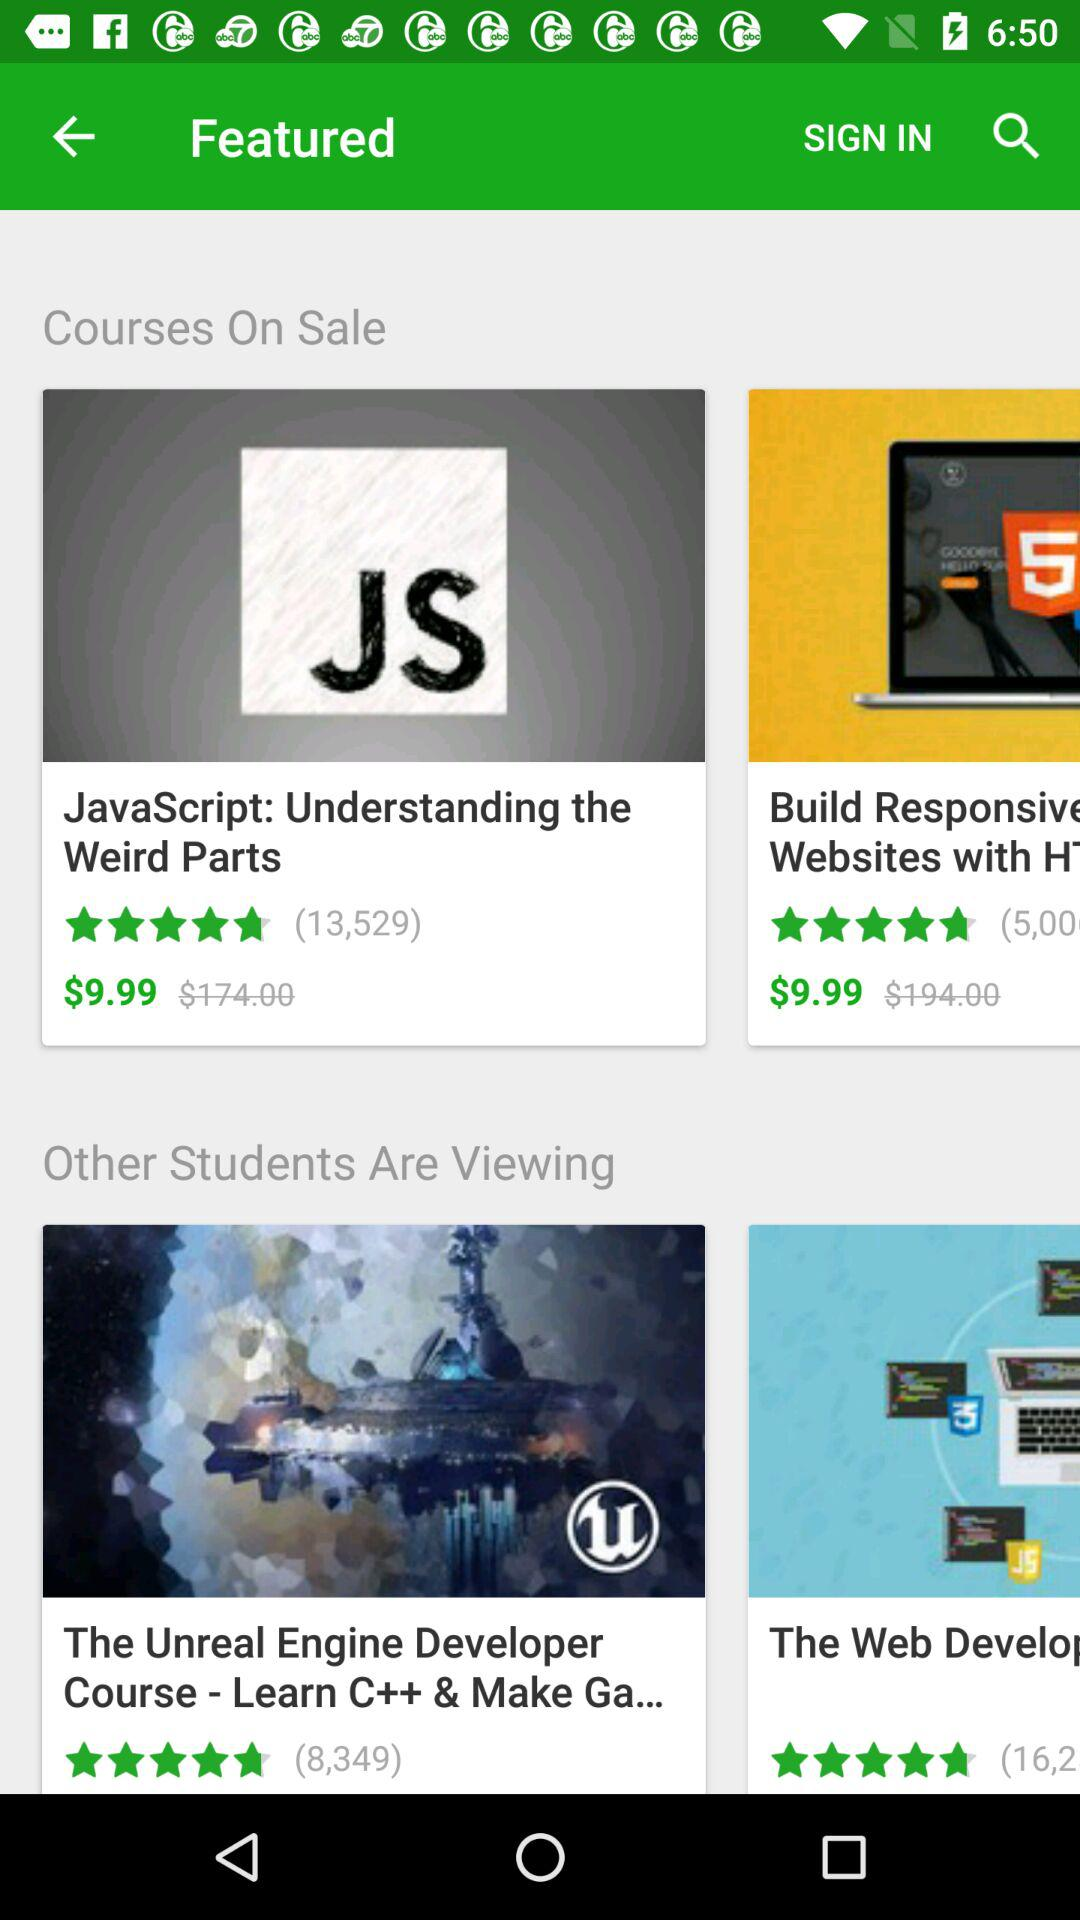What is the cost of "Javascript"? The cost is $9.99. 